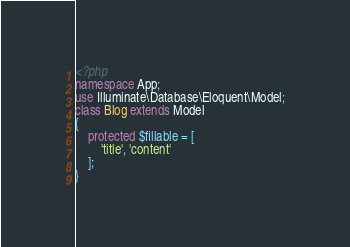<code> <loc_0><loc_0><loc_500><loc_500><_PHP_><?php 
namespace App;
use Illuminate\Database\Eloquent\Model;
class Blog extends Model
{
    protected $fillable = [
        'title', 'content'
    ];
}</code> 